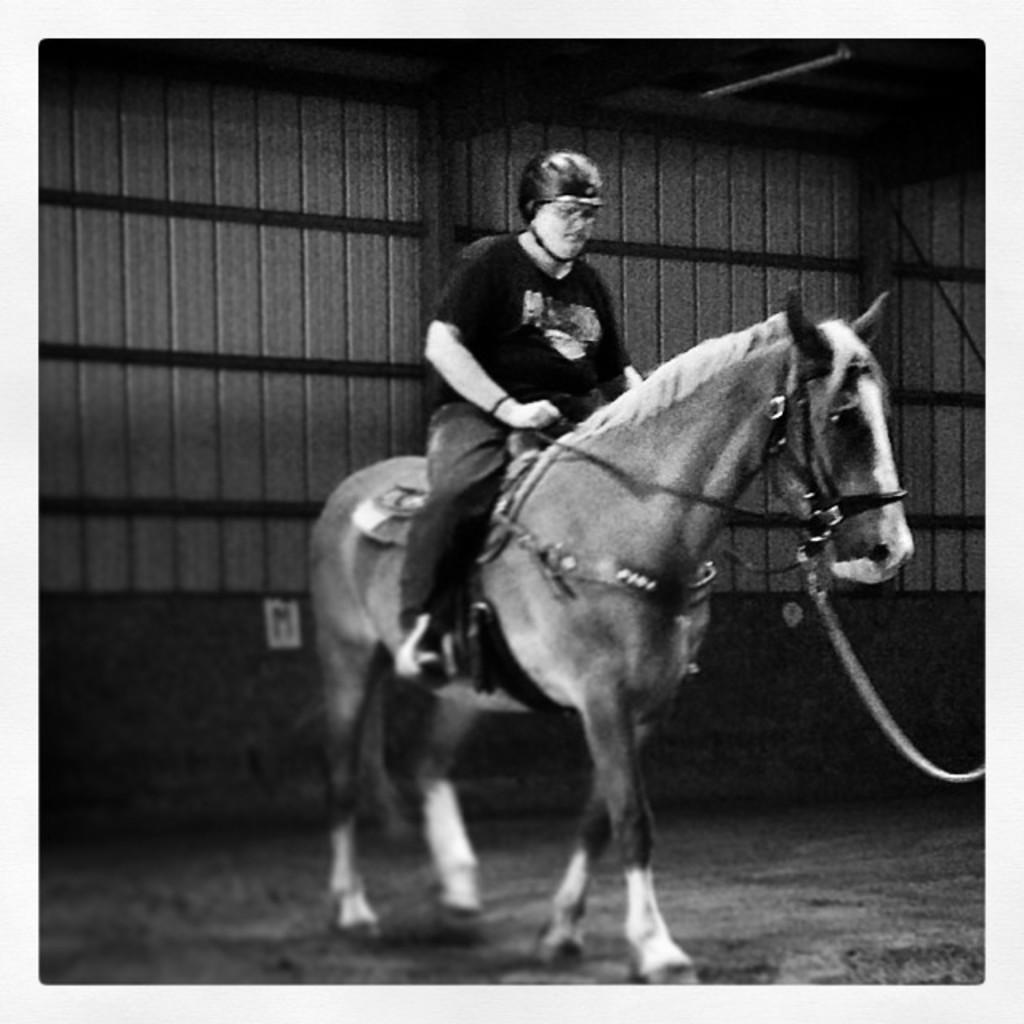What is the color scheme of the image? The image is black and white. Where was the image taken? The image was taken in a stable. What is the main subject of the image? There is a person riding a horse in the center of the image. What type of comb is being used by the horse in the image? There is no comb present in the image, and the horse is not using any comb. 